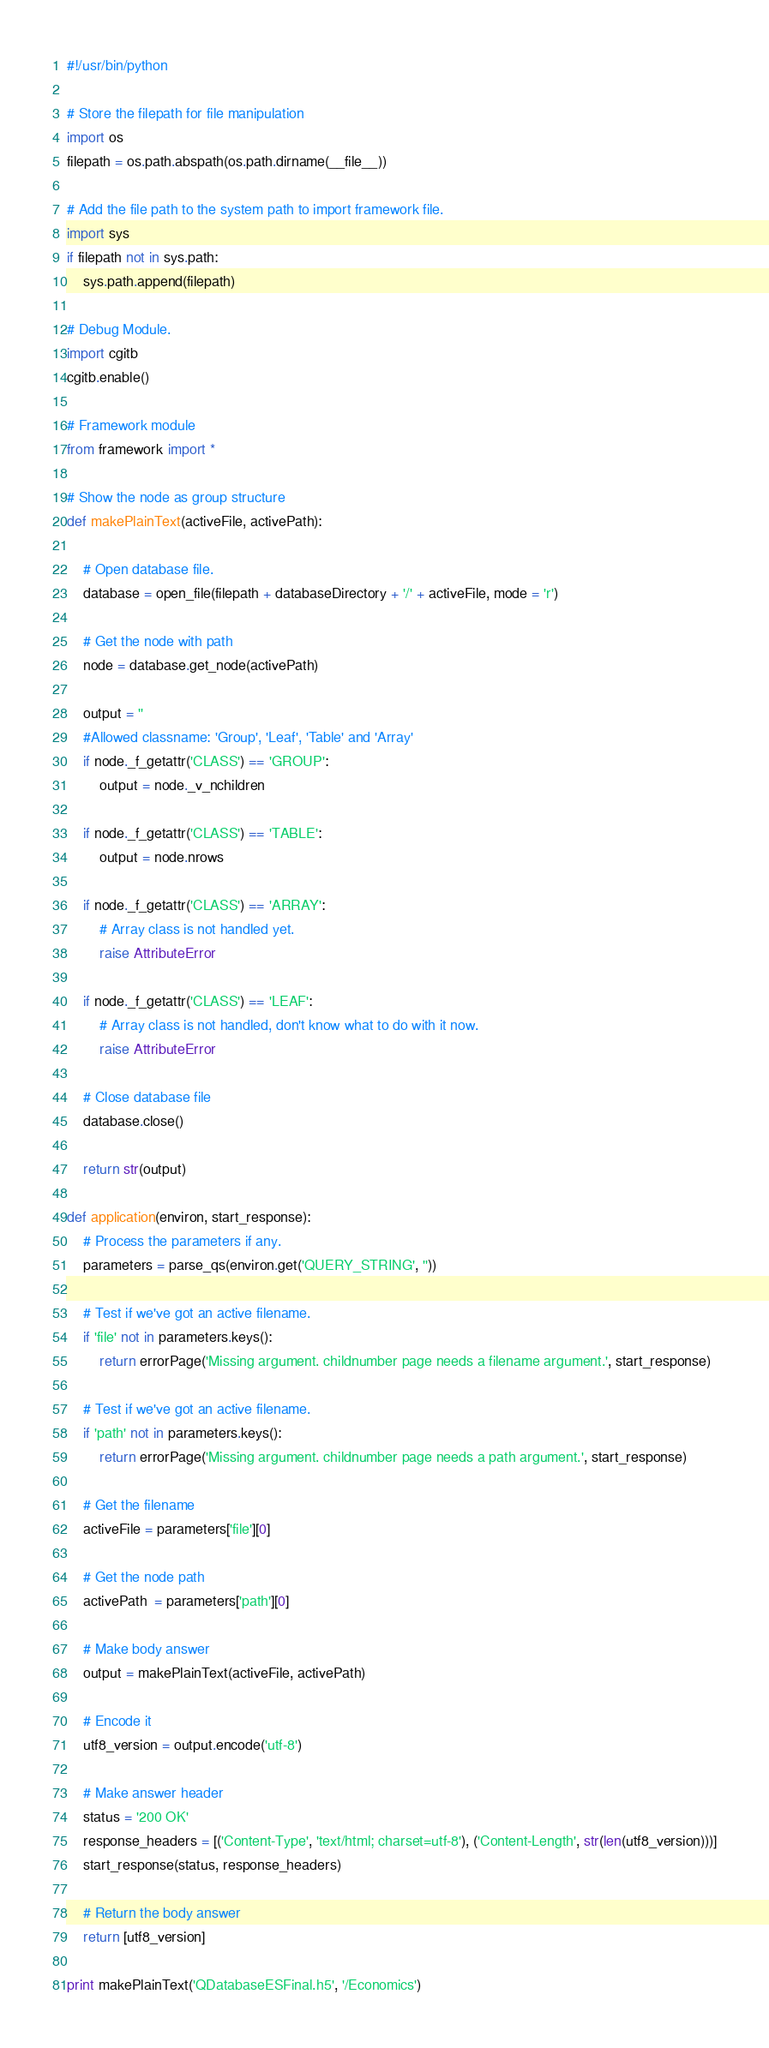Convert code to text. <code><loc_0><loc_0><loc_500><loc_500><_Python_>#!/usr/bin/python

# Store the filepath for file manipulation
import os
filepath = os.path.abspath(os.path.dirname(__file__))

# Add the file path to the system path to import framework file.
import sys
if filepath not in sys.path:
	sys.path.append(filepath)

# Debug Module.
import cgitb
cgitb.enable()

# Framework module
from framework import *

# Show the node as group structure
def makePlainText(activeFile, activePath):

	# Open database file.
	database = open_file(filepath + databaseDirectory + '/' + activeFile, mode = 'r')

	# Get the node with path
	node = database.get_node(activePath)

	output = ''	
	#Allowed classname: 'Group', 'Leaf', 'Table' and 'Array'
	if node._f_getattr('CLASS') == 'GROUP':
		output = node._v_nchildren

	if node._f_getattr('CLASS') == 'TABLE':
		output = node.nrows

	if node._f_getattr('CLASS') == 'ARRAY':
		# Array class is not handled yet.
		raise AttributeError

	if node._f_getattr('CLASS') == 'LEAF':
		# Array class is not handled, don't know what to do with it now.
		raise AttributeError

	# Close database file
	database.close()

	return str(output)

def application(environ, start_response):
	# Process the parameters if any.
	parameters = parse_qs(environ.get('QUERY_STRING', ''))

	# Test if we've got an active filename.
	if 'file' not in parameters.keys():
		return errorPage('Missing argument. childnumber page needs a filename argument.', start_response)

	# Test if we've got an active filename.
	if 'path' not in parameters.keys():
		return errorPage('Missing argument. childnumber page needs a path argument.', start_response)

	# Get the filename
	activeFile = parameters['file'][0]

	# Get the node path
	activePath  = parameters['path'][0]

	# Make body answer
	output = makePlainText(activeFile, activePath)

	# Encode it
	utf8_version = output.encode('utf-8')

	# Make answer header
	status = '200 OK'
	response_headers = [('Content-Type', 'text/html; charset=utf-8'), ('Content-Length', str(len(utf8_version)))]
	start_response(status, response_headers)

	# Return the body answer
	return [utf8_version]

print makePlainText('QDatabaseESFinal.h5', '/Economics')
</code> 